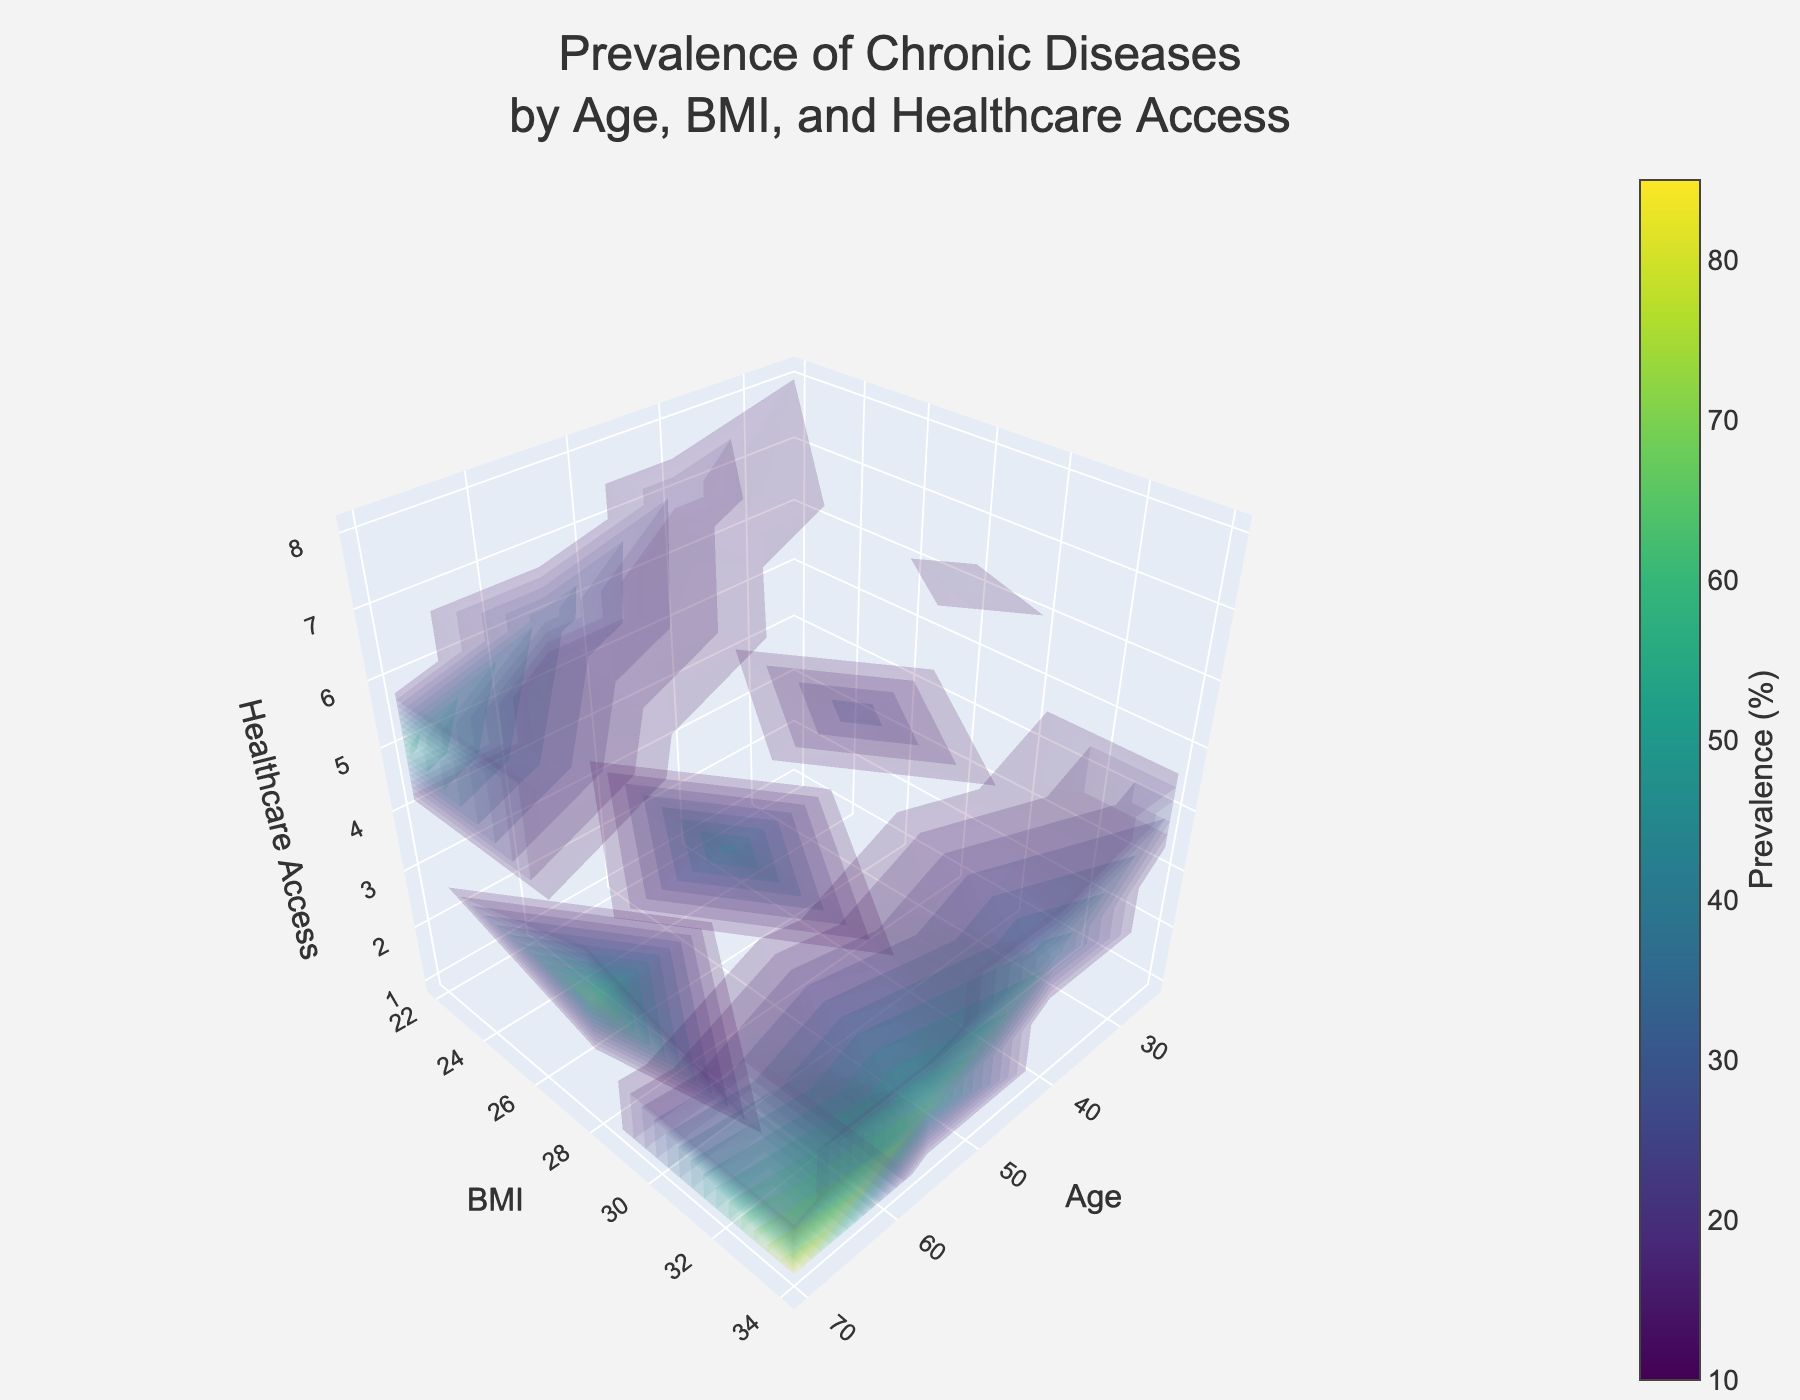What is the title of the plot? The title of the plot is displayed prominently at the top and it reads "Prevalence of Chronic Diseases by Age, BMI, and Healthcare Access".
Answer: Prevalence of Chronic Diseases by Age, BMI, and Healthcare Access What is the range of the prevalence of chronic diseases represented in the plot? The color bar on the right side of the plot indicates that the prevalence of chronic diseases ranges from 10% to 85%.
Answer: 10% to 85% How does prevalence of chronic diseases change as age increases from 25 to 70 at a BMI of 34? Observing the values on the plot at BMI level 34, the prevalence increases as age goes from 25 to 70, starting at 25% and ending at 85%.
Answer: Increases from 25% to 85% Which healthcare access level corresponds to the highest prevalence of chronic diseases at age 40 and a BMI of 28? The plot shows that for age 40 and a BMI of 28, the highest prevalence (30%) corresponds to a healthcare access level of 5.
Answer: Healthcare access level 5 What is the age and BMI for the point with the lowest prevalence of chronic diseases? By examining the plot, the lowest prevalence (10%) is found at age 25 and BMI 22.
Answer: Age 25, BMI 22 Is there a general trend in the prevalence of chronic diseases with decreasing healthcare access? By exploring the various levels of healthcare access on the plot, it is evident that the prevalence of chronic diseases tends to increase with decreasing healthcare access.
Answer: Yes, prevalence increases Is the prevalence of chronic diseases higher for a BMI of 28 or 34 at age 55 with healthcare access levels of 4? Observing the values for age 55 and healthcare access of 4, the prevalence is higher for a BMI of 34 (65%) compared to a BMI of 28 (50%).
Answer: Higher for BMI 34 What are the prevalence values for chronic diseases for people aged 25 with different BMIs but the same healthcare access of 6? For age 25 and healthcare access of 6, the plot shows prevalence values of 15% for BMI 28.
Answer: 15% for BMI 28, no data for others What overall impression can you give regarding the relationship between age, BMI, healthcare access, and the prevalence of chronic diseases? By examining the entire plot, a general pattern emerges: higher age and BMI combined with lower healthcare access are associated with a higher prevalence of chronic diseases. Conversely, younger age, lower BMI, and higher levels of healthcare access generally exhibit lower prevalence rates.
Answer: Higher age/BMI and lower healthcare access lead to higher prevalence; the opposite leads to lower prevalence Does the plot suggest any specific age group that should be prioritized for chronic disease interventions? The plot indicates that the age group of 70 has the highest prevalence of chronic diseases, especially at lower levels of healthcare access, suggesting a targeted intervention may be beneficial for this group.
Answer: Age group 70 